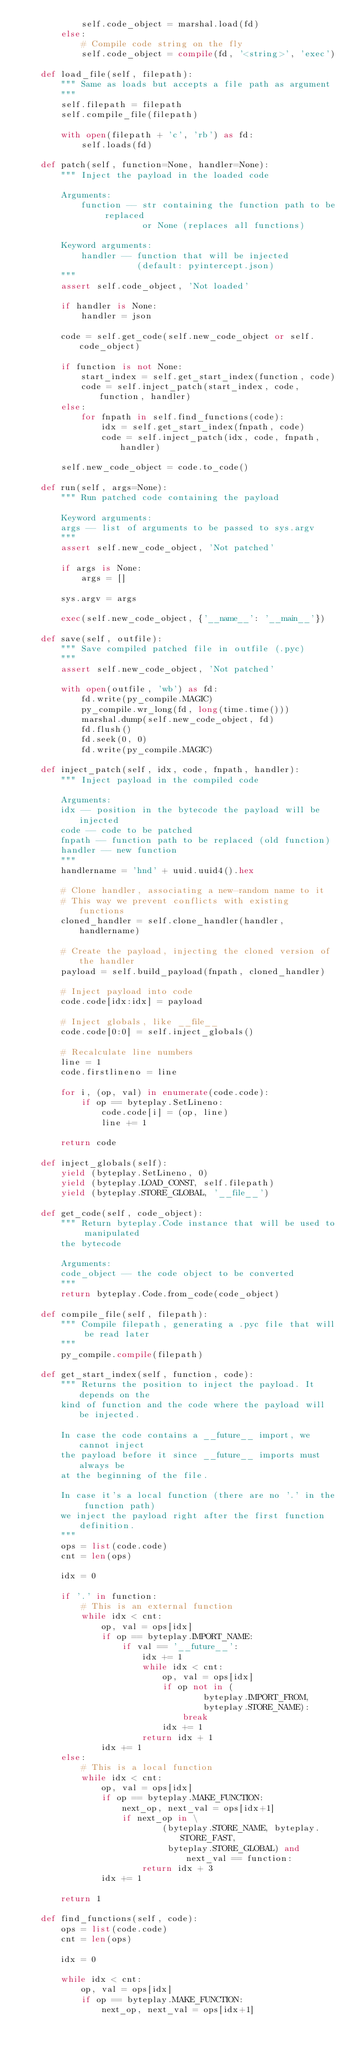<code> <loc_0><loc_0><loc_500><loc_500><_Python_>            self.code_object = marshal.load(fd)
        else:
            # Compile code string on the fly
            self.code_object = compile(fd, '<string>', 'exec')

    def load_file(self, filepath):
        """ Same as loads but accepts a file path as argument
        """
        self.filepath = filepath
        self.compile_file(filepath)

        with open(filepath + 'c', 'rb') as fd:
            self.loads(fd)

    def patch(self, function=None, handler=None):
        """ Inject the payload in the loaded code

        Arguments:
            function -- str containing the function path to be replaced
                        or None (replaces all functions)

        Keyword arguments:
            handler -- function that will be injected
                       (default: pyintercept.json)
        """
        assert self.code_object, 'Not loaded'

        if handler is None:
            handler = json

        code = self.get_code(self.new_code_object or self.code_object)

        if function is not None:
            start_index = self.get_start_index(function, code)
            code = self.inject_patch(start_index, code, function, handler)
        else:
            for fnpath in self.find_functions(code):
                idx = self.get_start_index(fnpath, code)
                code = self.inject_patch(idx, code, fnpath, handler)

        self.new_code_object = code.to_code()

    def run(self, args=None):
        """ Run patched code containing the payload

        Keyword arguments:
        args -- list of arguments to be passed to sys.argv
        """
        assert self.new_code_object, 'Not patched'

        if args is None:
            args = []

        sys.argv = args

        exec(self.new_code_object, {'__name__': '__main__'})

    def save(self, outfile):
        """ Save compiled patched file in outfile (.pyc)
        """
        assert self.new_code_object, 'Not patched'

        with open(outfile, 'wb') as fd:
            fd.write(py_compile.MAGIC)
            py_compile.wr_long(fd, long(time.time()))
            marshal.dump(self.new_code_object, fd)
            fd.flush()
            fd.seek(0, 0)
            fd.write(py_compile.MAGIC)

    def inject_patch(self, idx, code, fnpath, handler):
        """ Inject payload in the compiled code

        Arguments:
        idx -- position in the bytecode the payload will be injected
        code -- code to be patched
        fnpath -- function path to be replaced (old function)
        handler -- new function
        """
        handlername = 'hnd' + uuid.uuid4().hex

        # Clone handler, associating a new-random name to it
        # This way we prevent conflicts with existing functions
        cloned_handler = self.clone_handler(handler, handlername)

        # Create the payload, injecting the cloned version of the handler
        payload = self.build_payload(fnpath, cloned_handler)

        # Inject payload into code
        code.code[idx:idx] = payload

        # Inject globals, like __file__
        code.code[0:0] = self.inject_globals()

        # Recalculate line numbers
        line = 1
        code.firstlineno = line

        for i, (op, val) in enumerate(code.code):
            if op == byteplay.SetLineno:
                code.code[i] = (op, line)
                line += 1

        return code

    def inject_globals(self):
        yield (byteplay.SetLineno, 0)
        yield (byteplay.LOAD_CONST, self.filepath)
        yield (byteplay.STORE_GLOBAL, '__file__')

    def get_code(self, code_object):
        """ Return byteplay.Code instance that will be used to manipulated
        the bytecode

        Arguments:
        code_object -- the code object to be converted
        """
        return byteplay.Code.from_code(code_object)

    def compile_file(self, filepath):
        """ Compile filepath, generating a .pyc file that will be read later
        """
        py_compile.compile(filepath)

    def get_start_index(self, function, code):
        """ Returns the position to inject the payload. It depends on the
        kind of function and the code where the payload will be injected.

        In case the code contains a __future__ import, we cannot inject
        the payload before it since __future__ imports must always be
        at the beginning of the file.

        In case it's a local function (there are no '.' in the function path)
        we inject the payload right after the first function definition.
        """
        ops = list(code.code)
        cnt = len(ops)

        idx = 0

        if '.' in function:
            # This is an external function
            while idx < cnt:
                op, val = ops[idx]
                if op == byteplay.IMPORT_NAME:
                    if val == '__future__':
                        idx += 1
                        while idx < cnt:
                            op, val = ops[idx]
                            if op not in (
                                    byteplay.IMPORT_FROM,
                                    byteplay.STORE_NAME):
                                break
                            idx += 1
                        return idx + 1
                idx += 1
        else:
            # This is a local function
            while idx < cnt:
                op, val = ops[idx]
                if op == byteplay.MAKE_FUNCTION:
                    next_op, next_val = ops[idx+1]
                    if next_op in \
                            (byteplay.STORE_NAME, byteplay.STORE_FAST,
                             byteplay.STORE_GLOBAL) and next_val == function:
                        return idx + 3
                idx += 1

        return 1

    def find_functions(self, code):
        ops = list(code.code)
        cnt = len(ops)

        idx = 0

        while idx < cnt:
            op, val = ops[idx]
            if op == byteplay.MAKE_FUNCTION:
                next_op, next_val = ops[idx+1]</code> 